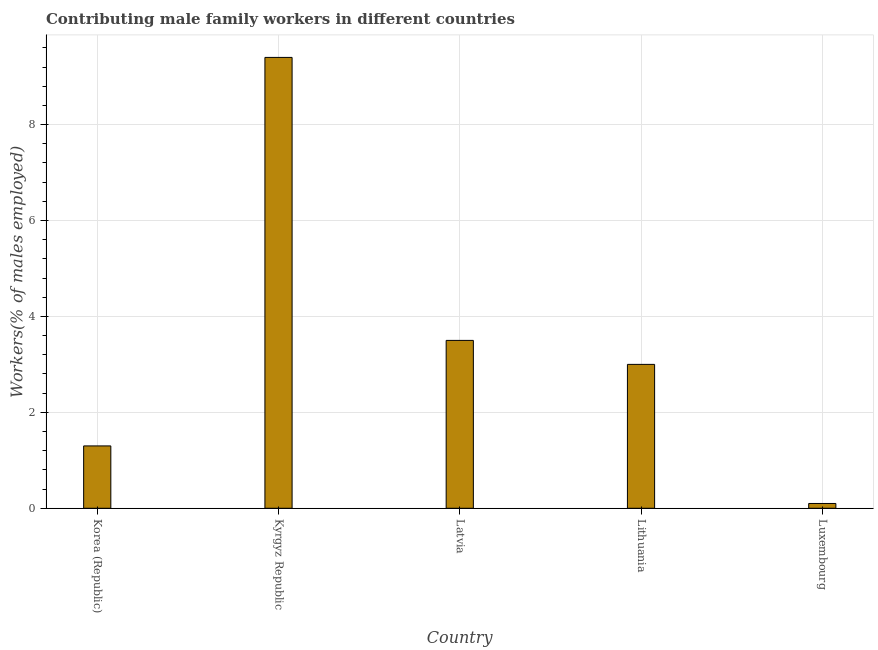What is the title of the graph?
Keep it short and to the point. Contributing male family workers in different countries. What is the label or title of the X-axis?
Offer a very short reply. Country. What is the label or title of the Y-axis?
Give a very brief answer. Workers(% of males employed). What is the contributing male family workers in Lithuania?
Provide a short and direct response. 3. Across all countries, what is the maximum contributing male family workers?
Offer a terse response. 9.4. Across all countries, what is the minimum contributing male family workers?
Your answer should be compact. 0.1. In which country was the contributing male family workers maximum?
Keep it short and to the point. Kyrgyz Republic. In which country was the contributing male family workers minimum?
Offer a very short reply. Luxembourg. What is the sum of the contributing male family workers?
Offer a very short reply. 17.3. What is the difference between the contributing male family workers in Korea (Republic) and Luxembourg?
Your answer should be compact. 1.2. What is the average contributing male family workers per country?
Your response must be concise. 3.46. What is the median contributing male family workers?
Offer a very short reply. 3. In how many countries, is the contributing male family workers greater than 8.4 %?
Ensure brevity in your answer.  1. What is the ratio of the contributing male family workers in Korea (Republic) to that in Latvia?
Your answer should be very brief. 0.37. Is the sum of the contributing male family workers in Lithuania and Luxembourg greater than the maximum contributing male family workers across all countries?
Your answer should be compact. No. What is the difference between the highest and the lowest contributing male family workers?
Your answer should be compact. 9.3. What is the difference between two consecutive major ticks on the Y-axis?
Offer a terse response. 2. Are the values on the major ticks of Y-axis written in scientific E-notation?
Offer a very short reply. No. What is the Workers(% of males employed) in Korea (Republic)?
Make the answer very short. 1.3. What is the Workers(% of males employed) of Kyrgyz Republic?
Make the answer very short. 9.4. What is the Workers(% of males employed) in Latvia?
Give a very brief answer. 3.5. What is the Workers(% of males employed) of Lithuania?
Give a very brief answer. 3. What is the Workers(% of males employed) in Luxembourg?
Give a very brief answer. 0.1. What is the difference between the Workers(% of males employed) in Korea (Republic) and Latvia?
Your answer should be very brief. -2.2. What is the difference between the Workers(% of males employed) in Korea (Republic) and Lithuania?
Make the answer very short. -1.7. What is the difference between the Workers(% of males employed) in Korea (Republic) and Luxembourg?
Your answer should be very brief. 1.2. What is the difference between the Workers(% of males employed) in Latvia and Lithuania?
Give a very brief answer. 0.5. What is the difference between the Workers(% of males employed) in Lithuania and Luxembourg?
Offer a terse response. 2.9. What is the ratio of the Workers(% of males employed) in Korea (Republic) to that in Kyrgyz Republic?
Offer a very short reply. 0.14. What is the ratio of the Workers(% of males employed) in Korea (Republic) to that in Latvia?
Provide a short and direct response. 0.37. What is the ratio of the Workers(% of males employed) in Korea (Republic) to that in Lithuania?
Provide a short and direct response. 0.43. What is the ratio of the Workers(% of males employed) in Kyrgyz Republic to that in Latvia?
Your answer should be compact. 2.69. What is the ratio of the Workers(% of males employed) in Kyrgyz Republic to that in Lithuania?
Your answer should be compact. 3.13. What is the ratio of the Workers(% of males employed) in Kyrgyz Republic to that in Luxembourg?
Ensure brevity in your answer.  94. What is the ratio of the Workers(% of males employed) in Latvia to that in Lithuania?
Provide a short and direct response. 1.17. What is the ratio of the Workers(% of males employed) in Latvia to that in Luxembourg?
Your response must be concise. 35. 